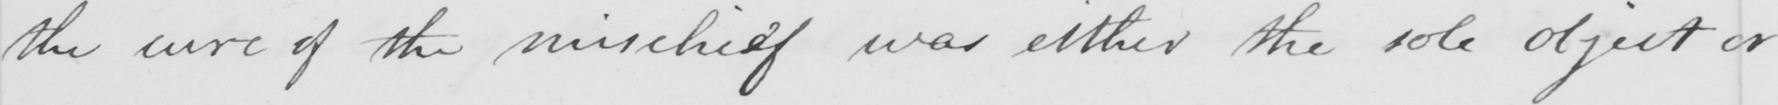Can you tell me what this handwritten text says? the cure of the mischief was either the sole object or 